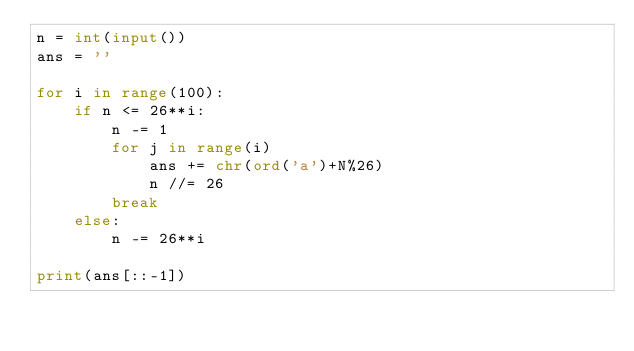<code> <loc_0><loc_0><loc_500><loc_500><_Python_>n = int(input())
ans = ''

for i in range(100):
    if n <= 26**i:
        n -= 1
        for j in range(i)
            ans += chr(ord('a')+N%26)
            n //= 26
        break
    else:
        n -= 26**i

print(ans[::-1])</code> 